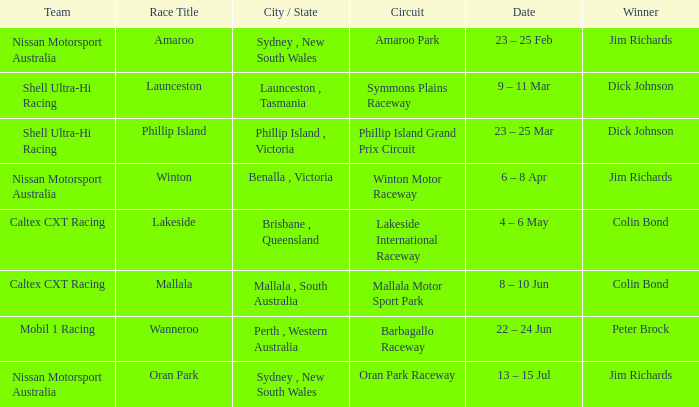Name the team for launceston Shell Ultra-Hi Racing. 